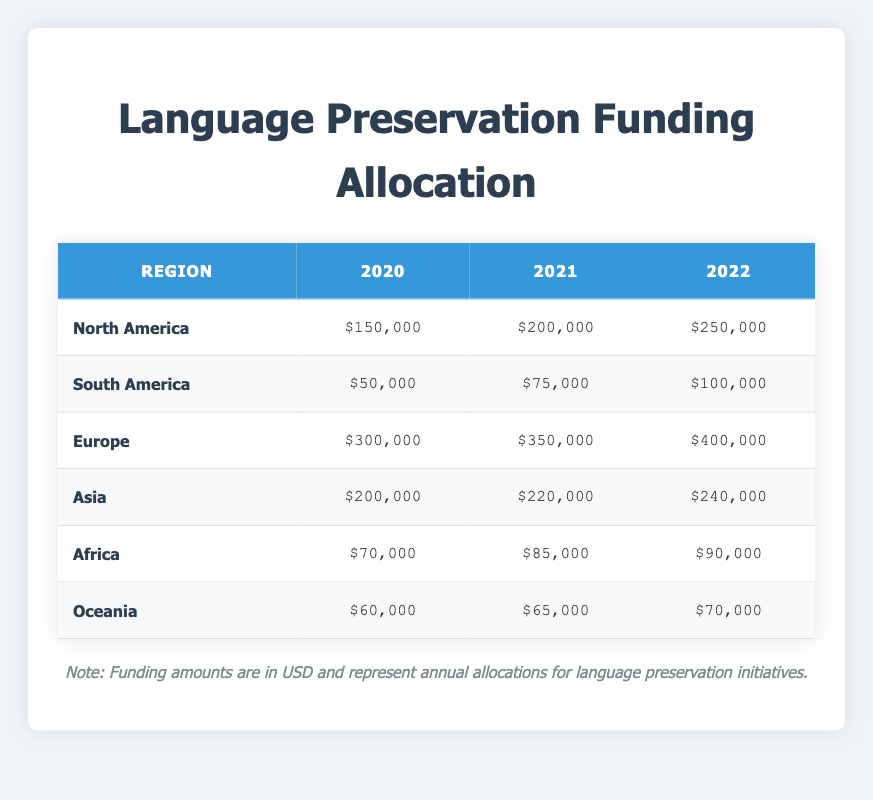What was the funding amount for North America in 2021? From the table, the funding amount specified for North America in the year 2021 is $200,000.
Answer: $200,000 Which region received the highest funding in 2022? In the table, the highest funding amount in 2022 is seen under Europe, which received $400,000.
Answer: Europe What is the total funding allocated to South America for the years 2020, 2021, and 2022? Adding the funding amounts from South America: 2020 ($50,000) + 2021 ($75,000) + 2022 ($100,000) gives a total of $225,000.
Answer: $225,000 Did Oceania's funding increase every year from 2020 to 2022? A review of the table shows that Oceania's funding went from $60,000 in 2020 to $65,000 in 2021 and then to $70,000 in 2022, indicating an increase each year.
Answer: Yes What was the average funding amount for Asia over the three years? For Asia, the funding amounts are $200,000 (2020), $220,000 (2021), and $240,000 (2022). The total is $200,000 + $220,000 + $240,000 = $660,000. Dividing this by 3 gives an average of $220,000.
Answer: $220,000 Is the funding amount for Africa in 2021 greater than that for Oceania in the same year? The funding amount for Africa in 2021 is $85,000, while that for Oceania is $65,000; therefore, Africa's funding is greater.
Answer: Yes Which region experienced the lowest funding amount in 2020? By comparing all the funding amounts in 2020, South America received $50,000, which is the lowest compared to the other regions.
Answer: South America What was the difference in funding for North America between 2020 and 2022? The funding for North America in 2020 was $150,000, while in 2022 it was $250,000. The difference is calculated as $250,000 - $150,000 = $100,000.
Answer: $100,000 